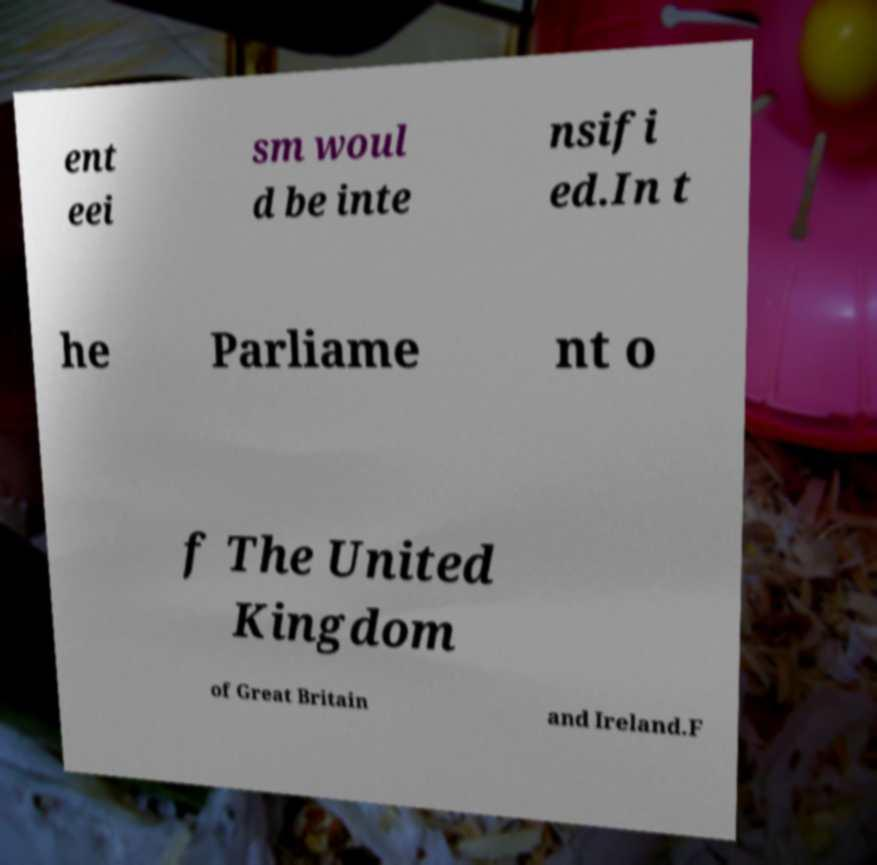Could you assist in decoding the text presented in this image and type it out clearly? ent eei sm woul d be inte nsifi ed.In t he Parliame nt o f The United Kingdom of Great Britain and Ireland.F 